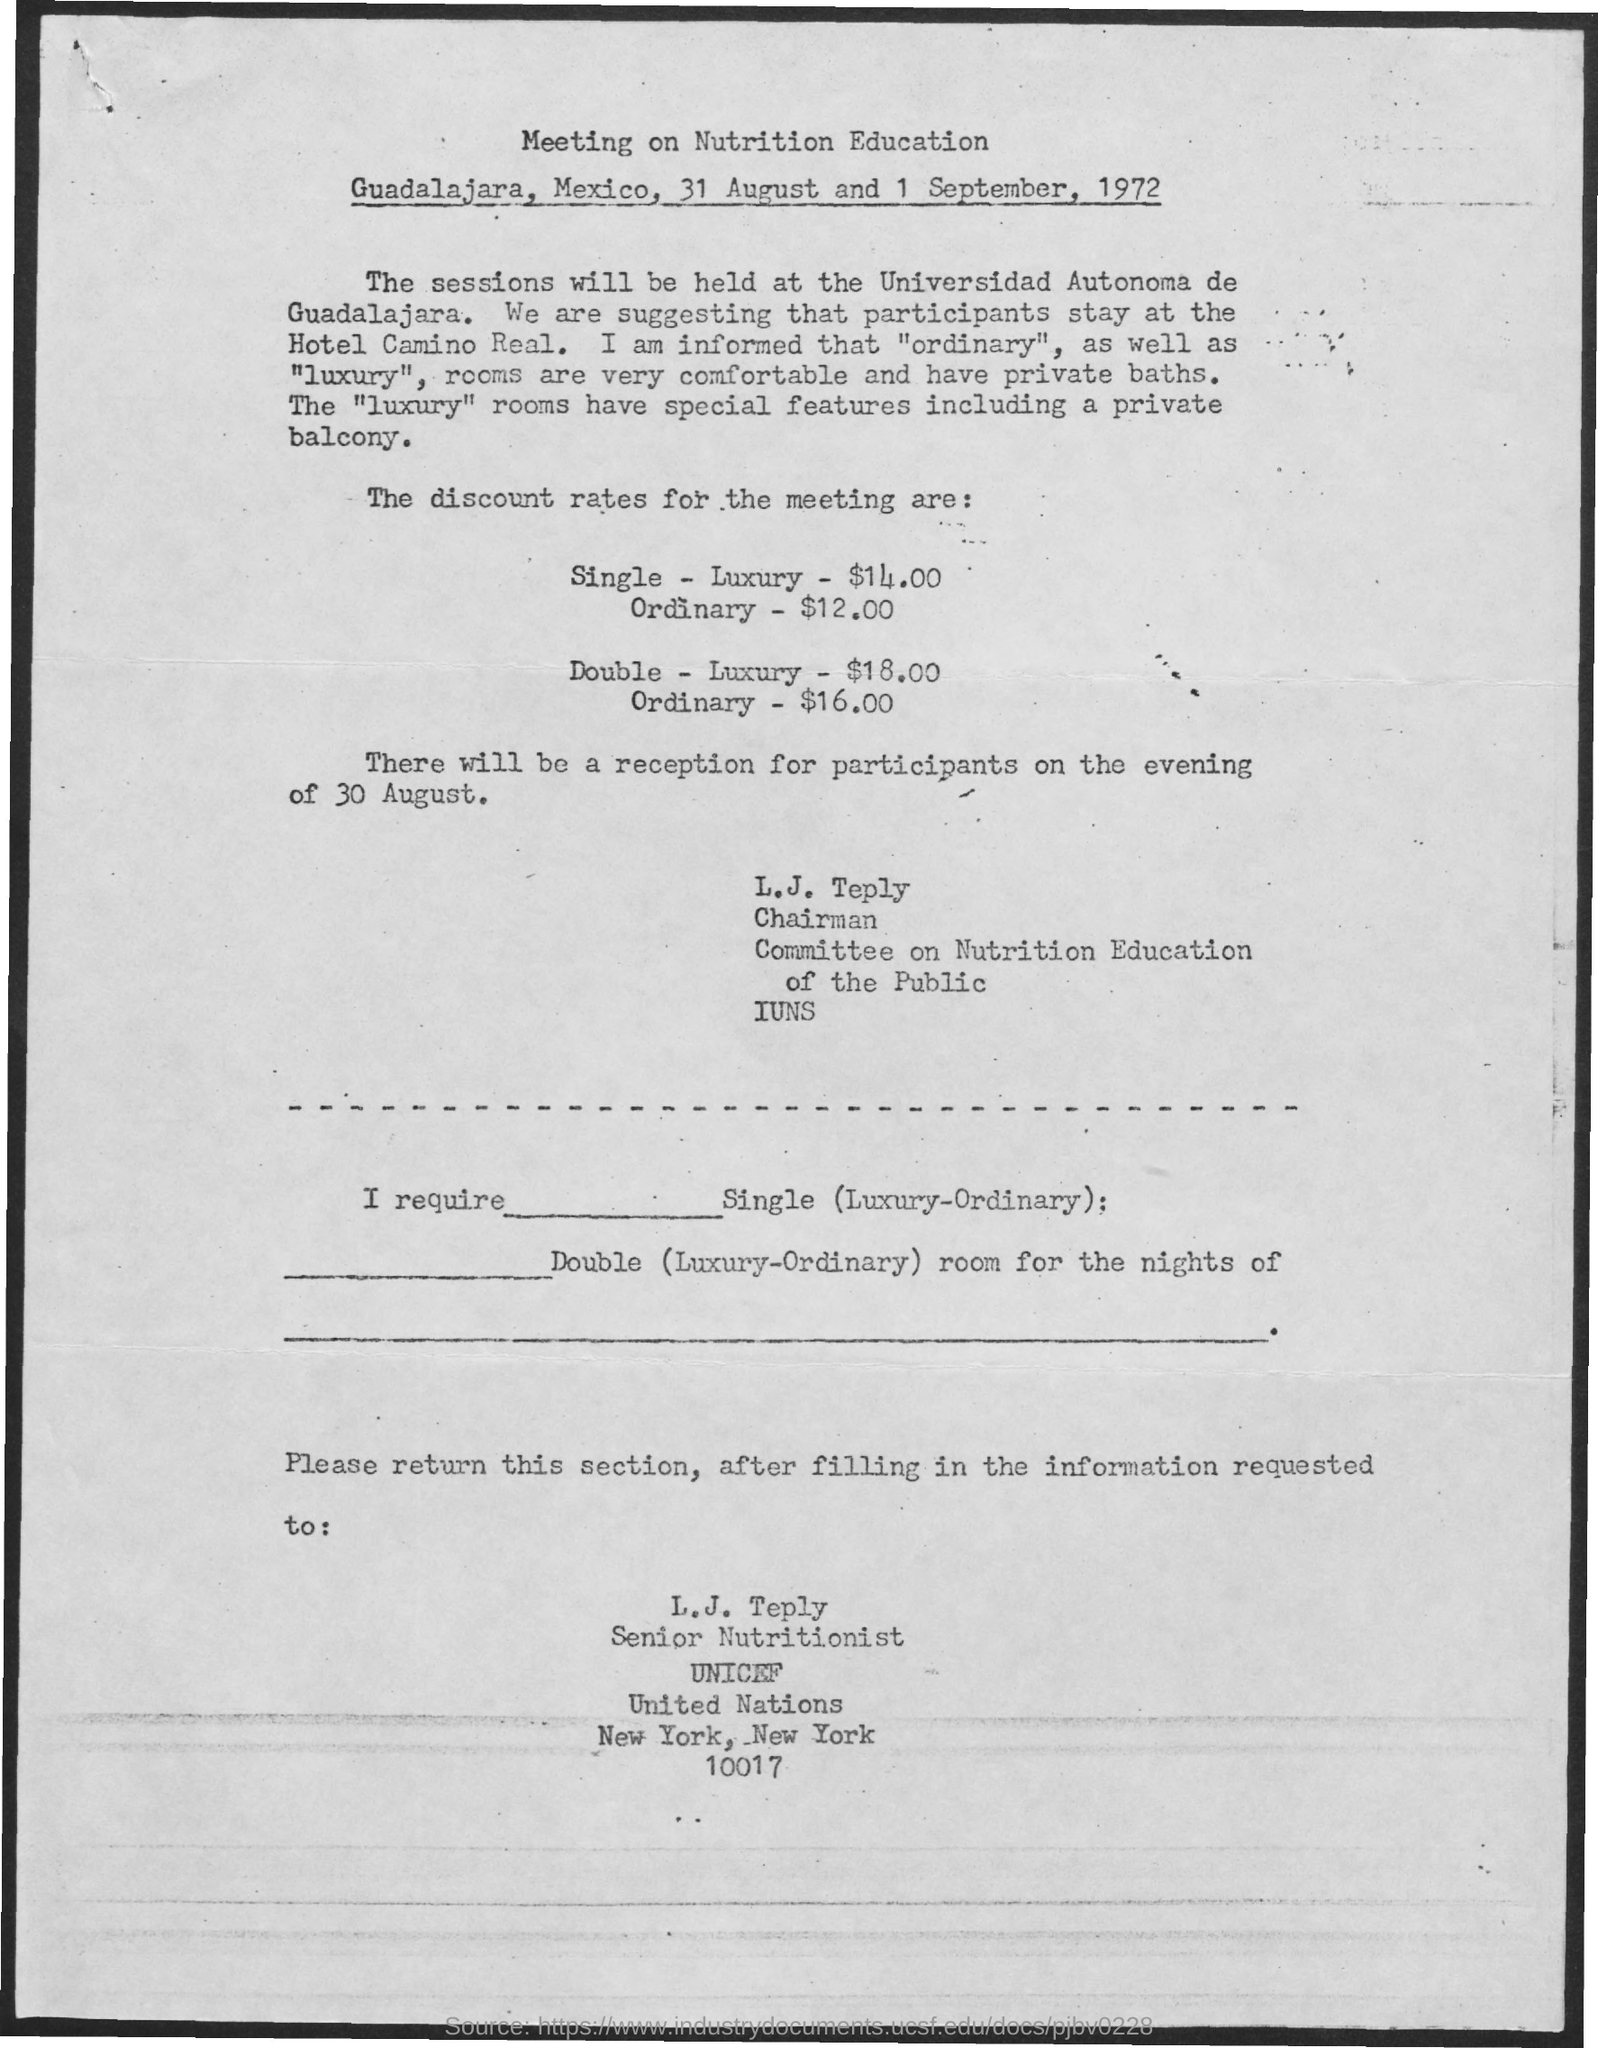Indicate a few pertinent items in this graphic. The form should be sent to L.J. Teply. The discount rate for a meeting for single-luxury is $14.00. The discount rate for the meeting for Double - luxury rooms is $18.00. The discount rate for the meeting for Double - Ordinary is $16.00. The participants are being advised to stay at the Hotel Camino Real. 